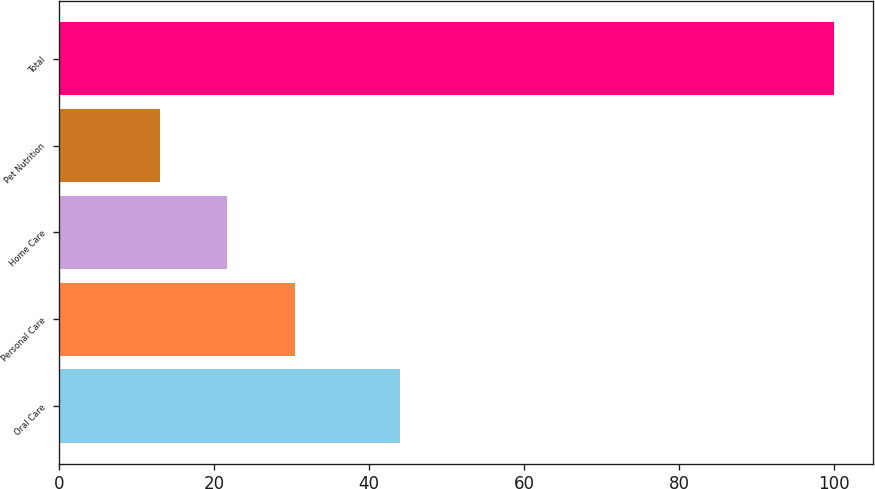Convert chart to OTSL. <chart><loc_0><loc_0><loc_500><loc_500><bar_chart><fcel>Oral Care<fcel>Personal Care<fcel>Home Care<fcel>Pet Nutrition<fcel>Total<nl><fcel>44<fcel>30.4<fcel>21.7<fcel>13<fcel>100<nl></chart> 